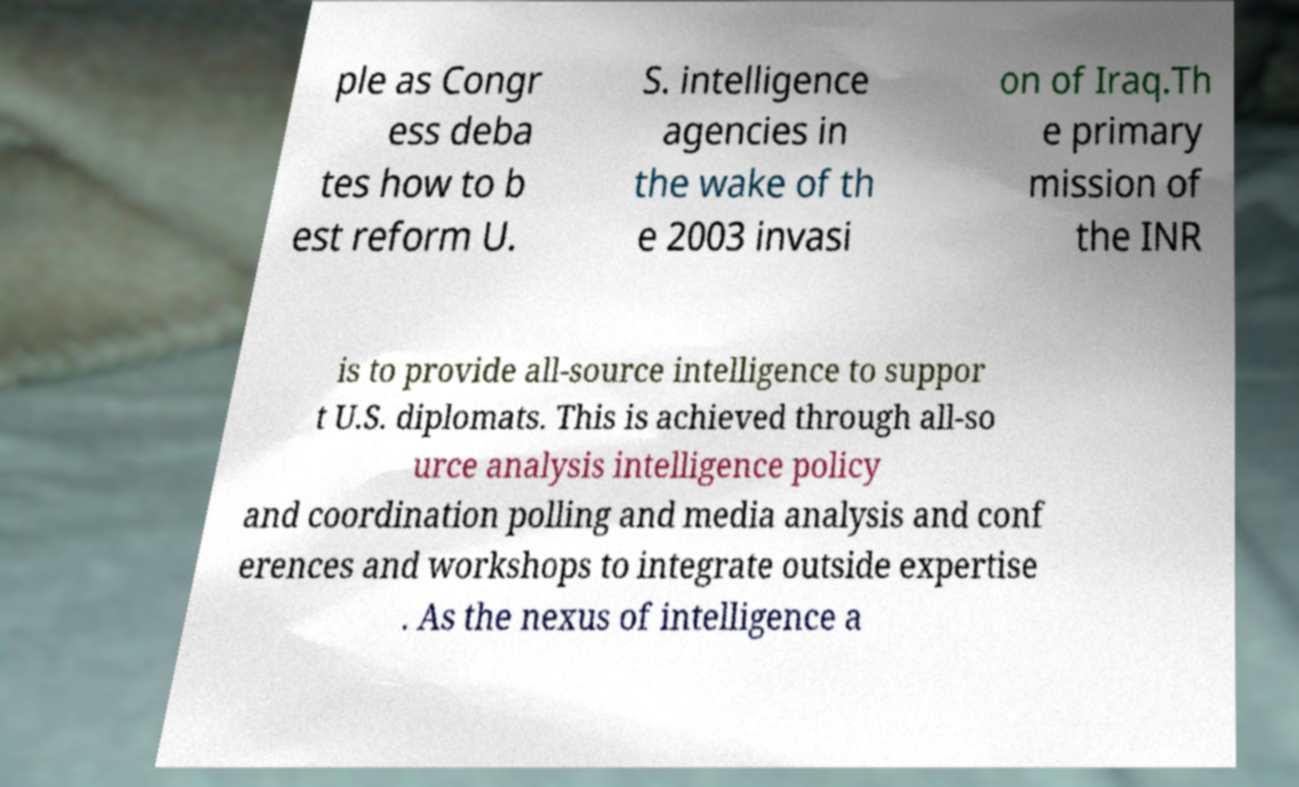Could you assist in decoding the text presented in this image and type it out clearly? ple as Congr ess deba tes how to b est reform U. S. intelligence agencies in the wake of th e 2003 invasi on of Iraq.Th e primary mission of the INR is to provide all-source intelligence to suppor t U.S. diplomats. This is achieved through all-so urce analysis intelligence policy and coordination polling and media analysis and conf erences and workshops to integrate outside expertise . As the nexus of intelligence a 